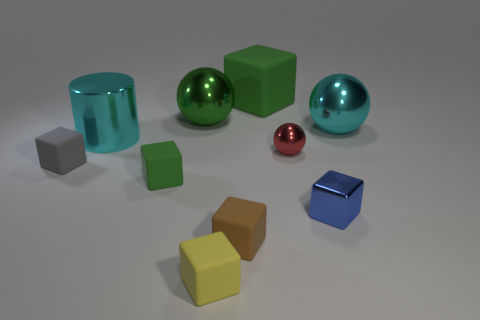There is a green block to the left of the yellow thing; what size is it?
Your answer should be compact. Small. What material is the tiny cube that is the same color as the large matte thing?
Offer a terse response. Rubber. What color is the ball that is the same size as the blue shiny cube?
Keep it short and to the point. Red. Is the red object the same size as the green sphere?
Offer a very short reply. No. There is a matte thing that is in front of the small blue shiny block and left of the tiny brown matte thing; what size is it?
Offer a terse response. Small. How many metallic objects are green objects or brown balls?
Ensure brevity in your answer.  1. Are there more spheres on the right side of the big green rubber block than tiny blue rubber blocks?
Your response must be concise. Yes. What is the green cube that is behind the large cyan metal ball made of?
Your answer should be very brief. Rubber. How many objects have the same material as the blue cube?
Your response must be concise. 4. The small matte thing that is both right of the cylinder and to the left of the small yellow object has what shape?
Provide a succinct answer. Cube. 